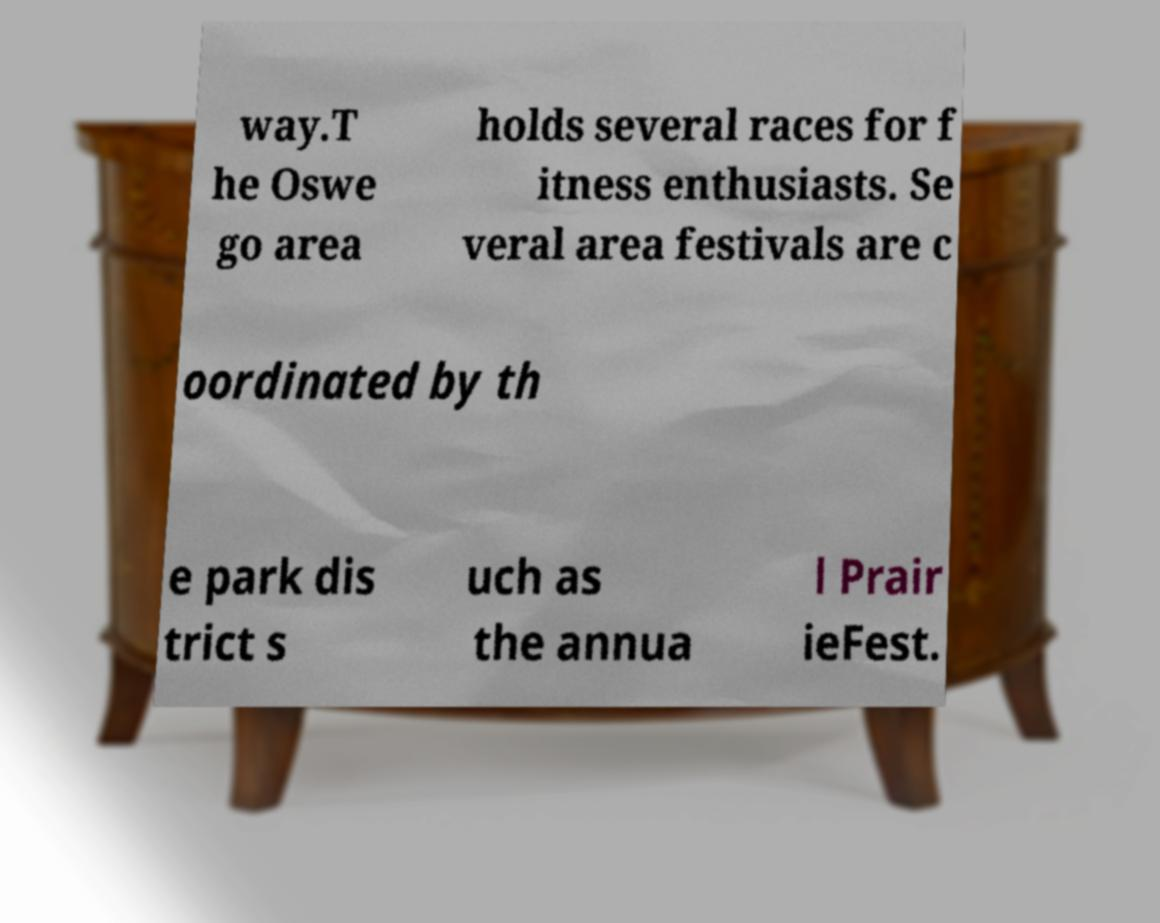Please identify and transcribe the text found in this image. way.T he Oswe go area holds several races for f itness enthusiasts. Se veral area festivals are c oordinated by th e park dis trict s uch as the annua l Prair ieFest. 